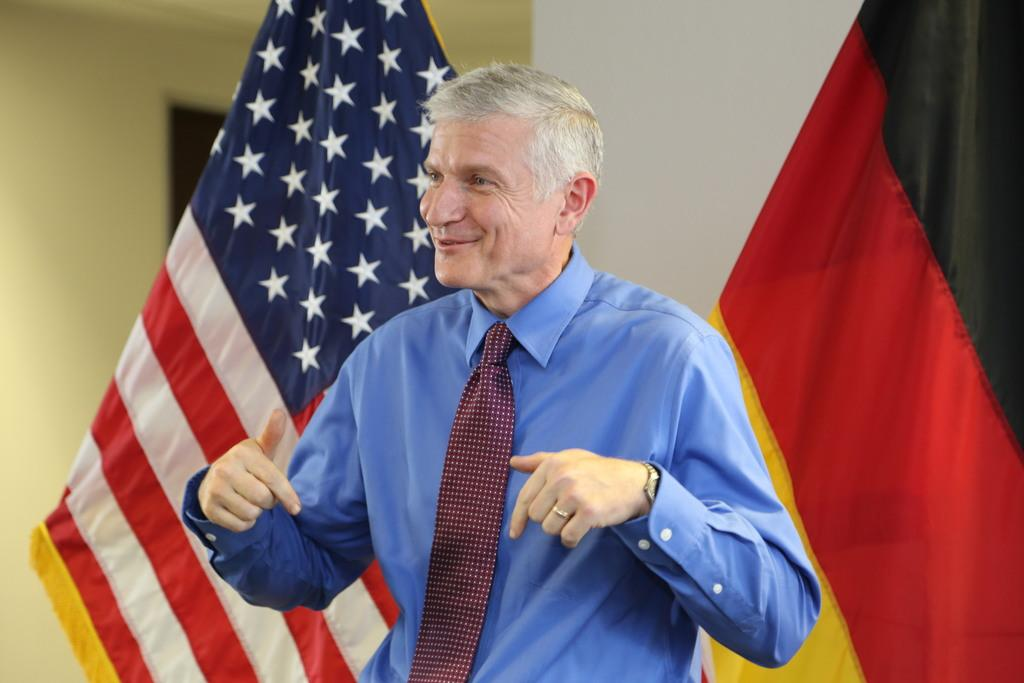Who or what is present in the image? There is a person in the image. How is the person's facial expression? The person has a smile on their face. What can be seen in the image besides the person? There are flags visible in the image. What type of architectural features can be seen in the background? There is a door and walls in the background of the image. What type of curtain is hanging over the bed in the image? There is no curtain or bed present in the image. 